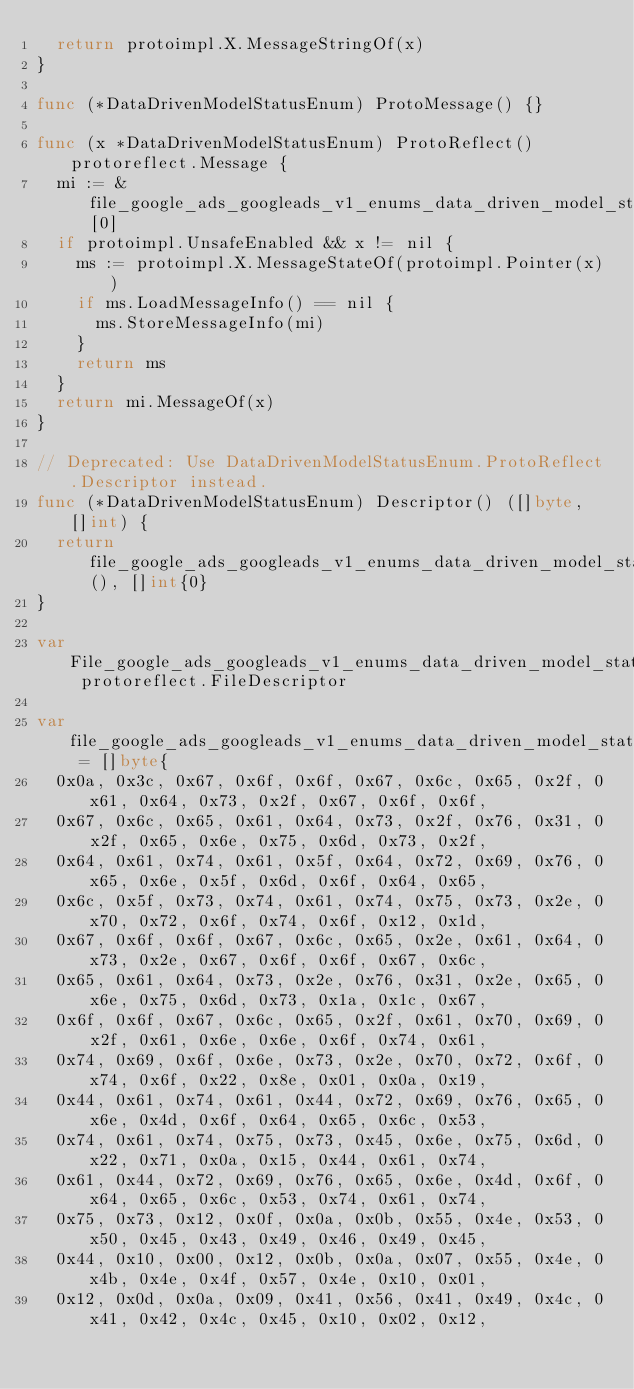<code> <loc_0><loc_0><loc_500><loc_500><_Go_>	return protoimpl.X.MessageStringOf(x)
}

func (*DataDrivenModelStatusEnum) ProtoMessage() {}

func (x *DataDrivenModelStatusEnum) ProtoReflect() protoreflect.Message {
	mi := &file_google_ads_googleads_v1_enums_data_driven_model_status_proto_msgTypes[0]
	if protoimpl.UnsafeEnabled && x != nil {
		ms := protoimpl.X.MessageStateOf(protoimpl.Pointer(x))
		if ms.LoadMessageInfo() == nil {
			ms.StoreMessageInfo(mi)
		}
		return ms
	}
	return mi.MessageOf(x)
}

// Deprecated: Use DataDrivenModelStatusEnum.ProtoReflect.Descriptor instead.
func (*DataDrivenModelStatusEnum) Descriptor() ([]byte, []int) {
	return file_google_ads_googleads_v1_enums_data_driven_model_status_proto_rawDescGZIP(), []int{0}
}

var File_google_ads_googleads_v1_enums_data_driven_model_status_proto protoreflect.FileDescriptor

var file_google_ads_googleads_v1_enums_data_driven_model_status_proto_rawDesc = []byte{
	0x0a, 0x3c, 0x67, 0x6f, 0x6f, 0x67, 0x6c, 0x65, 0x2f, 0x61, 0x64, 0x73, 0x2f, 0x67, 0x6f, 0x6f,
	0x67, 0x6c, 0x65, 0x61, 0x64, 0x73, 0x2f, 0x76, 0x31, 0x2f, 0x65, 0x6e, 0x75, 0x6d, 0x73, 0x2f,
	0x64, 0x61, 0x74, 0x61, 0x5f, 0x64, 0x72, 0x69, 0x76, 0x65, 0x6e, 0x5f, 0x6d, 0x6f, 0x64, 0x65,
	0x6c, 0x5f, 0x73, 0x74, 0x61, 0x74, 0x75, 0x73, 0x2e, 0x70, 0x72, 0x6f, 0x74, 0x6f, 0x12, 0x1d,
	0x67, 0x6f, 0x6f, 0x67, 0x6c, 0x65, 0x2e, 0x61, 0x64, 0x73, 0x2e, 0x67, 0x6f, 0x6f, 0x67, 0x6c,
	0x65, 0x61, 0x64, 0x73, 0x2e, 0x76, 0x31, 0x2e, 0x65, 0x6e, 0x75, 0x6d, 0x73, 0x1a, 0x1c, 0x67,
	0x6f, 0x6f, 0x67, 0x6c, 0x65, 0x2f, 0x61, 0x70, 0x69, 0x2f, 0x61, 0x6e, 0x6e, 0x6f, 0x74, 0x61,
	0x74, 0x69, 0x6f, 0x6e, 0x73, 0x2e, 0x70, 0x72, 0x6f, 0x74, 0x6f, 0x22, 0x8e, 0x01, 0x0a, 0x19,
	0x44, 0x61, 0x74, 0x61, 0x44, 0x72, 0x69, 0x76, 0x65, 0x6e, 0x4d, 0x6f, 0x64, 0x65, 0x6c, 0x53,
	0x74, 0x61, 0x74, 0x75, 0x73, 0x45, 0x6e, 0x75, 0x6d, 0x22, 0x71, 0x0a, 0x15, 0x44, 0x61, 0x74,
	0x61, 0x44, 0x72, 0x69, 0x76, 0x65, 0x6e, 0x4d, 0x6f, 0x64, 0x65, 0x6c, 0x53, 0x74, 0x61, 0x74,
	0x75, 0x73, 0x12, 0x0f, 0x0a, 0x0b, 0x55, 0x4e, 0x53, 0x50, 0x45, 0x43, 0x49, 0x46, 0x49, 0x45,
	0x44, 0x10, 0x00, 0x12, 0x0b, 0x0a, 0x07, 0x55, 0x4e, 0x4b, 0x4e, 0x4f, 0x57, 0x4e, 0x10, 0x01,
	0x12, 0x0d, 0x0a, 0x09, 0x41, 0x56, 0x41, 0x49, 0x4c, 0x41, 0x42, 0x4c, 0x45, 0x10, 0x02, 0x12,</code> 